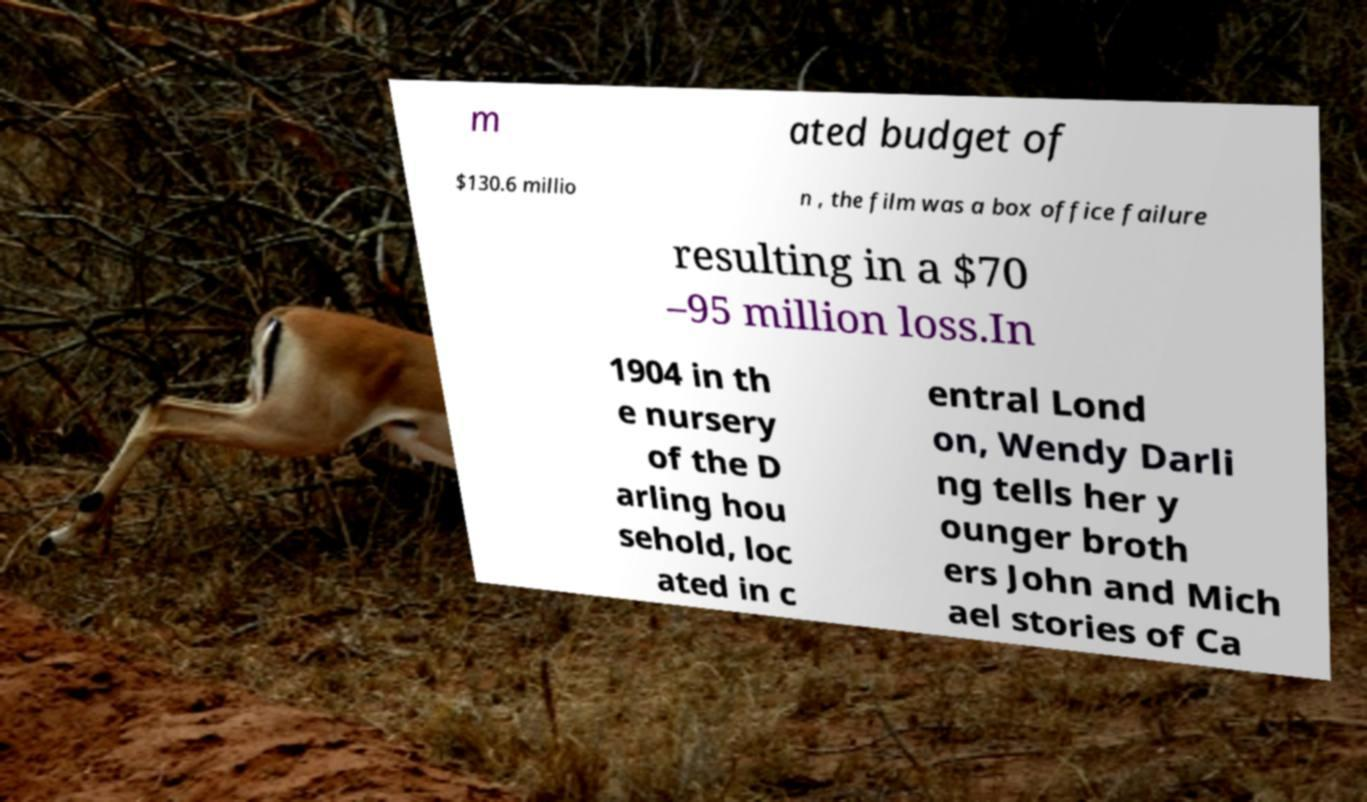Please identify and transcribe the text found in this image. m ated budget of $130.6 millio n , the film was a box office failure resulting in a $70 –95 million loss.In 1904 in th e nursery of the D arling hou sehold, loc ated in c entral Lond on, Wendy Darli ng tells her y ounger broth ers John and Mich ael stories of Ca 